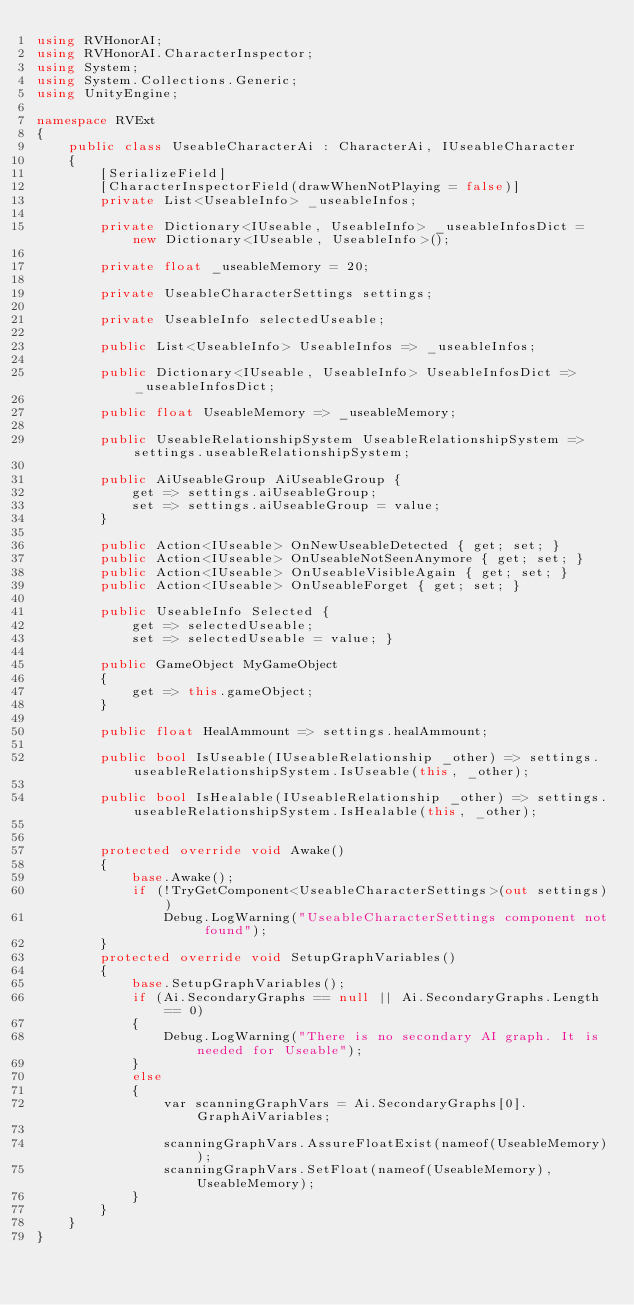Convert code to text. <code><loc_0><loc_0><loc_500><loc_500><_C#_>using RVHonorAI;
using RVHonorAI.CharacterInspector;
using System;
using System.Collections.Generic;
using UnityEngine;

namespace RVExt
{
    public class UseableCharacterAi : CharacterAi, IUseableCharacter
    {
        [SerializeField]
        [CharacterInspectorField(drawWhenNotPlaying = false)]
        private List<UseableInfo> _useableInfos;

        private Dictionary<IUseable, UseableInfo> _useableInfosDict = new Dictionary<IUseable, UseableInfo>();

        private float _useableMemory = 20;

        private UseableCharacterSettings settings;

        private UseableInfo selectedUseable;

        public List<UseableInfo> UseableInfos => _useableInfos;

        public Dictionary<IUseable, UseableInfo> UseableInfosDict => _useableInfosDict;

        public float UseableMemory => _useableMemory;

        public UseableRelationshipSystem UseableRelationshipSystem => settings.useableRelationshipSystem;

        public AiUseableGroup AiUseableGroup { 
            get => settings.aiUseableGroup;
            set => settings.aiUseableGroup = value; 
        }

        public Action<IUseable> OnNewUseableDetected { get; set; }
        public Action<IUseable> OnUseableNotSeenAnymore { get; set; }
        public Action<IUseable> OnUseableVisibleAgain { get; set; }
        public Action<IUseable> OnUseableForget { get; set; }

        public UseableInfo Selected { 
            get => selectedUseable;
            set => selectedUseable = value; }

        public GameObject MyGameObject
        {
            get => this.gameObject;
        }

        public float HealAmmount => settings.healAmmount;

        public bool IsUseable(IUseableRelationship _other) => settings.useableRelationshipSystem.IsUseable(this, _other);

        public bool IsHealable(IUseableRelationship _other) => settings.useableRelationshipSystem.IsHealable(this, _other);


        protected override void Awake()
        {
            base.Awake();
            if (!TryGetComponent<UseableCharacterSettings>(out settings))
                Debug.LogWarning("UseableCharacterSettings component not found");
        }
        protected override void SetupGraphVariables()
        {
            base.SetupGraphVariables();
            if (Ai.SecondaryGraphs == null || Ai.SecondaryGraphs.Length == 0)
            {
                Debug.LogWarning("There is no secondary AI graph. It is needed for Useable");
            }
            else
            {
                var scanningGraphVars = Ai.SecondaryGraphs[0].GraphAiVariables;

                scanningGraphVars.AssureFloatExist(nameof(UseableMemory));
                scanningGraphVars.SetFloat(nameof(UseableMemory), UseableMemory);
            }
        }
    }
}
</code> 